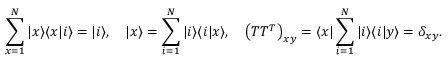<formula> <loc_0><loc_0><loc_500><loc_500>\sum _ { x = 1 } ^ { N } | x \rangle \langle x | i \rangle = | i \rangle , \quad | x \rangle = \sum _ { i = 1 } ^ { N } | i \rangle \langle i | x \rangle , \quad \left ( T T ^ { T } \right ) _ { x y } = \langle x | \sum _ { i = 1 } ^ { N } | i \rangle \langle i | y \rangle = \delta _ { x y } .</formula> 